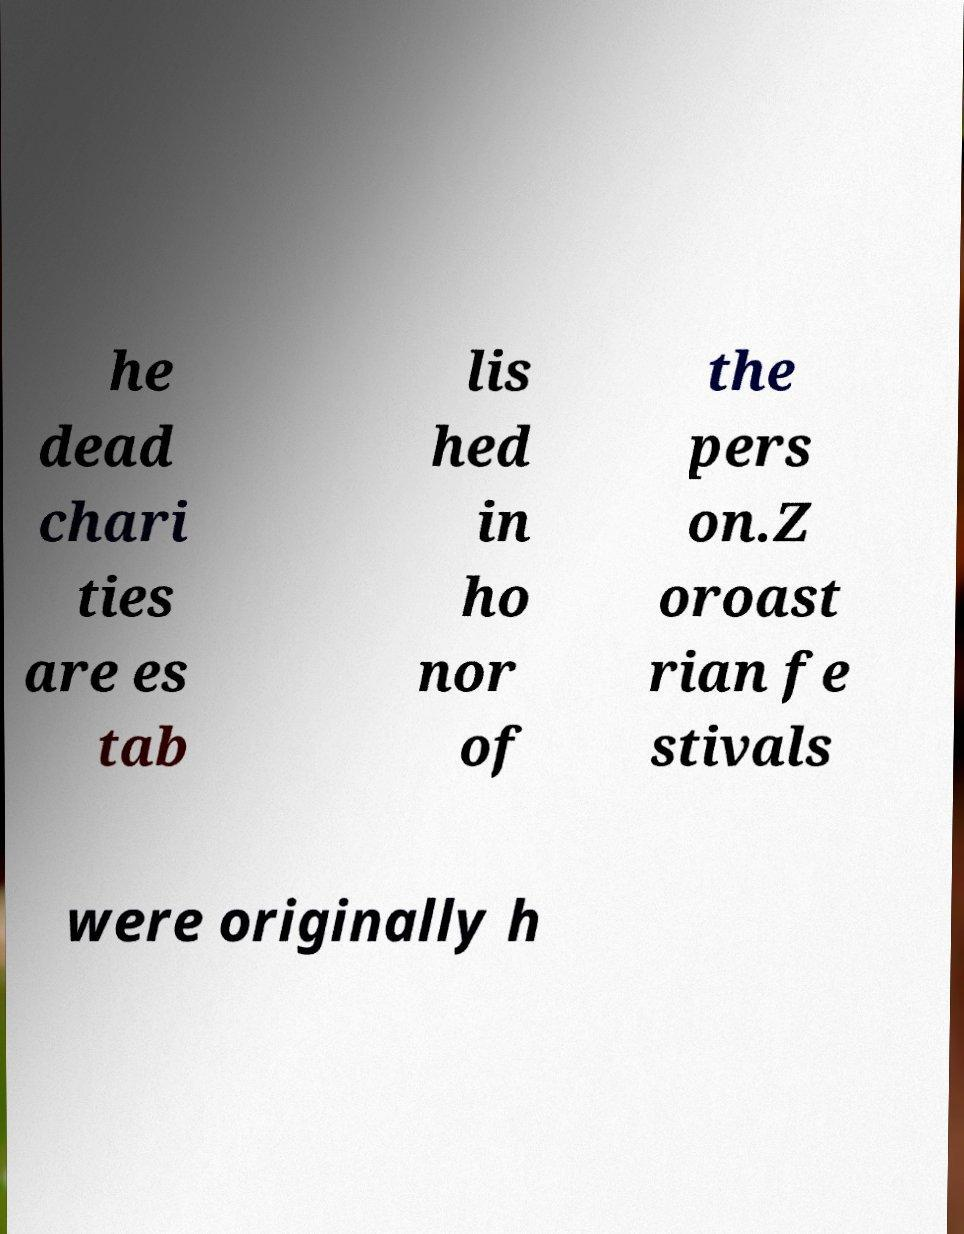Could you extract and type out the text from this image? he dead chari ties are es tab lis hed in ho nor of the pers on.Z oroast rian fe stivals were originally h 